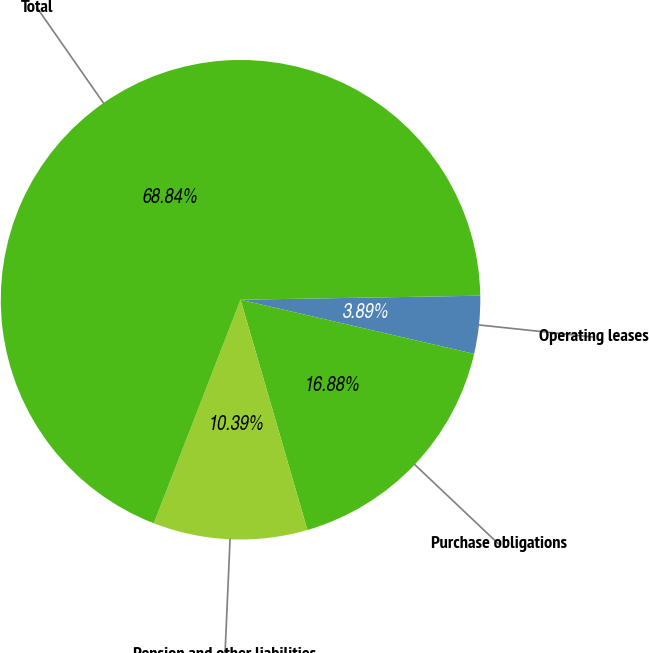<chart> <loc_0><loc_0><loc_500><loc_500><pie_chart><fcel>Operating leases<fcel>Purchase obligations<fcel>Pension and other liabilities<fcel>Total<nl><fcel>3.89%<fcel>16.88%<fcel>10.39%<fcel>68.84%<nl></chart> 